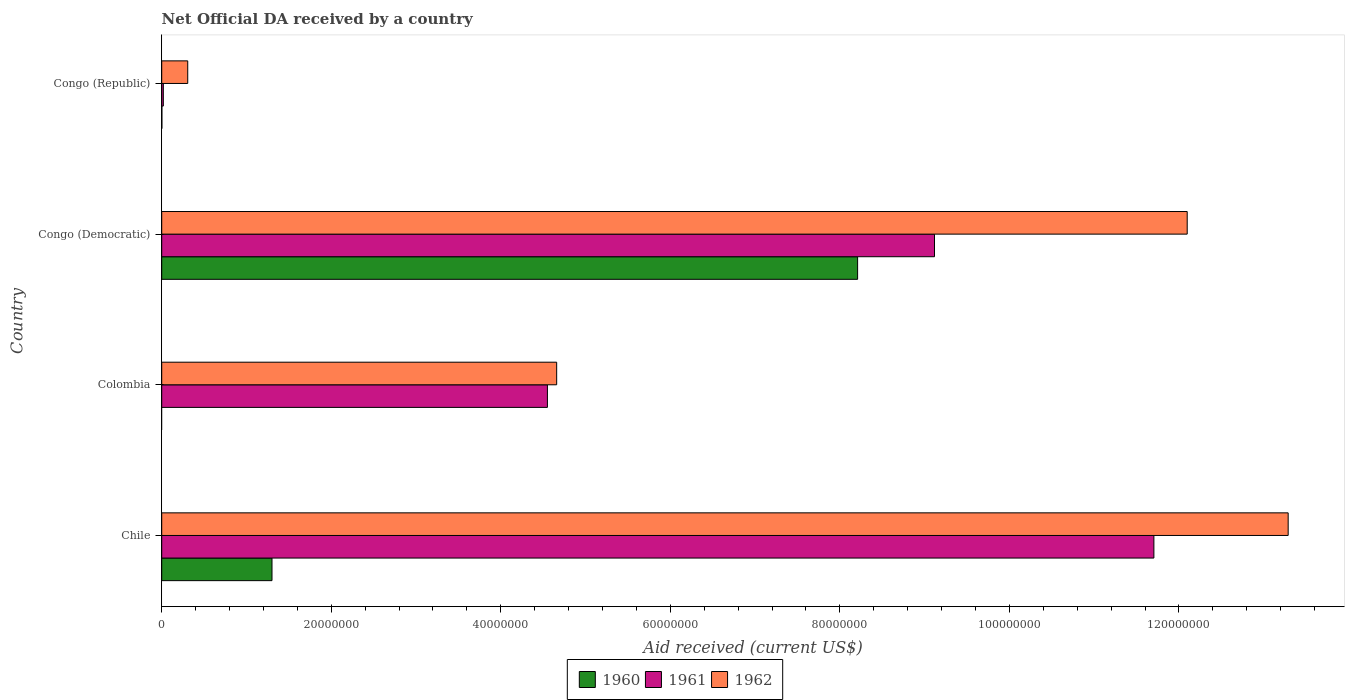How many different coloured bars are there?
Make the answer very short. 3. How many groups of bars are there?
Provide a short and direct response. 4. How many bars are there on the 1st tick from the top?
Offer a terse response. 3. What is the label of the 4th group of bars from the top?
Give a very brief answer. Chile. In how many cases, is the number of bars for a given country not equal to the number of legend labels?
Keep it short and to the point. 1. What is the net official development assistance aid received in 1962 in Chile?
Ensure brevity in your answer.  1.33e+08. Across all countries, what is the maximum net official development assistance aid received in 1962?
Make the answer very short. 1.33e+08. Across all countries, what is the minimum net official development assistance aid received in 1961?
Offer a terse response. 1.90e+05. In which country was the net official development assistance aid received in 1961 maximum?
Make the answer very short. Chile. What is the total net official development assistance aid received in 1961 in the graph?
Make the answer very short. 2.54e+08. What is the difference between the net official development assistance aid received in 1962 in Colombia and that in Congo (Democratic)?
Offer a terse response. -7.44e+07. What is the difference between the net official development assistance aid received in 1960 in Congo (Republic) and the net official development assistance aid received in 1961 in Colombia?
Your answer should be compact. -4.55e+07. What is the average net official development assistance aid received in 1960 per country?
Give a very brief answer. 2.38e+07. What is the difference between the net official development assistance aid received in 1962 and net official development assistance aid received in 1961 in Chile?
Ensure brevity in your answer.  1.58e+07. In how many countries, is the net official development assistance aid received in 1961 greater than 48000000 US$?
Give a very brief answer. 2. What is the ratio of the net official development assistance aid received in 1960 in Chile to that in Congo (Democratic)?
Your response must be concise. 0.16. What is the difference between the highest and the second highest net official development assistance aid received in 1962?
Provide a short and direct response. 1.19e+07. What is the difference between the highest and the lowest net official development assistance aid received in 1960?
Give a very brief answer. 8.21e+07. Is the sum of the net official development assistance aid received in 1960 in Chile and Congo (Democratic) greater than the maximum net official development assistance aid received in 1962 across all countries?
Provide a succinct answer. No. How many countries are there in the graph?
Your answer should be very brief. 4. What is the difference between two consecutive major ticks on the X-axis?
Provide a succinct answer. 2.00e+07. Are the values on the major ticks of X-axis written in scientific E-notation?
Your answer should be very brief. No. Does the graph contain any zero values?
Provide a succinct answer. Yes. Does the graph contain grids?
Offer a very short reply. No. Where does the legend appear in the graph?
Keep it short and to the point. Bottom center. How many legend labels are there?
Ensure brevity in your answer.  3. How are the legend labels stacked?
Make the answer very short. Horizontal. What is the title of the graph?
Provide a succinct answer. Net Official DA received by a country. What is the label or title of the X-axis?
Offer a very short reply. Aid received (current US$). What is the Aid received (current US$) of 1960 in Chile?
Offer a very short reply. 1.30e+07. What is the Aid received (current US$) of 1961 in Chile?
Keep it short and to the point. 1.17e+08. What is the Aid received (current US$) of 1962 in Chile?
Make the answer very short. 1.33e+08. What is the Aid received (current US$) of 1961 in Colombia?
Your response must be concise. 4.55e+07. What is the Aid received (current US$) of 1962 in Colombia?
Your response must be concise. 4.66e+07. What is the Aid received (current US$) in 1960 in Congo (Democratic)?
Keep it short and to the point. 8.21e+07. What is the Aid received (current US$) in 1961 in Congo (Democratic)?
Offer a terse response. 9.12e+07. What is the Aid received (current US$) of 1962 in Congo (Democratic)?
Ensure brevity in your answer.  1.21e+08. What is the Aid received (current US$) of 1960 in Congo (Republic)?
Provide a short and direct response. 2.00e+04. What is the Aid received (current US$) of 1962 in Congo (Republic)?
Make the answer very short. 3.07e+06. Across all countries, what is the maximum Aid received (current US$) of 1960?
Provide a succinct answer. 8.21e+07. Across all countries, what is the maximum Aid received (current US$) of 1961?
Offer a terse response. 1.17e+08. Across all countries, what is the maximum Aid received (current US$) in 1962?
Keep it short and to the point. 1.33e+08. Across all countries, what is the minimum Aid received (current US$) of 1961?
Keep it short and to the point. 1.90e+05. Across all countries, what is the minimum Aid received (current US$) in 1962?
Offer a terse response. 3.07e+06. What is the total Aid received (current US$) in 1960 in the graph?
Offer a terse response. 9.51e+07. What is the total Aid received (current US$) of 1961 in the graph?
Give a very brief answer. 2.54e+08. What is the total Aid received (current US$) in 1962 in the graph?
Offer a very short reply. 3.04e+08. What is the difference between the Aid received (current US$) of 1961 in Chile and that in Colombia?
Your response must be concise. 7.15e+07. What is the difference between the Aid received (current US$) of 1962 in Chile and that in Colombia?
Offer a terse response. 8.63e+07. What is the difference between the Aid received (current US$) of 1960 in Chile and that in Congo (Democratic)?
Make the answer very short. -6.91e+07. What is the difference between the Aid received (current US$) in 1961 in Chile and that in Congo (Democratic)?
Your response must be concise. 2.59e+07. What is the difference between the Aid received (current US$) of 1962 in Chile and that in Congo (Democratic)?
Your answer should be compact. 1.19e+07. What is the difference between the Aid received (current US$) in 1960 in Chile and that in Congo (Republic)?
Give a very brief answer. 1.30e+07. What is the difference between the Aid received (current US$) in 1961 in Chile and that in Congo (Republic)?
Provide a succinct answer. 1.17e+08. What is the difference between the Aid received (current US$) of 1962 in Chile and that in Congo (Republic)?
Your answer should be very brief. 1.30e+08. What is the difference between the Aid received (current US$) of 1961 in Colombia and that in Congo (Democratic)?
Offer a very short reply. -4.57e+07. What is the difference between the Aid received (current US$) in 1962 in Colombia and that in Congo (Democratic)?
Ensure brevity in your answer.  -7.44e+07. What is the difference between the Aid received (current US$) in 1961 in Colombia and that in Congo (Republic)?
Your answer should be very brief. 4.53e+07. What is the difference between the Aid received (current US$) in 1962 in Colombia and that in Congo (Republic)?
Offer a terse response. 4.35e+07. What is the difference between the Aid received (current US$) in 1960 in Congo (Democratic) and that in Congo (Republic)?
Give a very brief answer. 8.21e+07. What is the difference between the Aid received (current US$) of 1961 in Congo (Democratic) and that in Congo (Republic)?
Offer a terse response. 9.10e+07. What is the difference between the Aid received (current US$) in 1962 in Congo (Democratic) and that in Congo (Republic)?
Provide a succinct answer. 1.18e+08. What is the difference between the Aid received (current US$) of 1960 in Chile and the Aid received (current US$) of 1961 in Colombia?
Provide a succinct answer. -3.25e+07. What is the difference between the Aid received (current US$) in 1960 in Chile and the Aid received (current US$) in 1962 in Colombia?
Provide a succinct answer. -3.36e+07. What is the difference between the Aid received (current US$) of 1961 in Chile and the Aid received (current US$) of 1962 in Colombia?
Your response must be concise. 7.04e+07. What is the difference between the Aid received (current US$) of 1960 in Chile and the Aid received (current US$) of 1961 in Congo (Democratic)?
Your response must be concise. -7.82e+07. What is the difference between the Aid received (current US$) in 1960 in Chile and the Aid received (current US$) in 1962 in Congo (Democratic)?
Your answer should be compact. -1.08e+08. What is the difference between the Aid received (current US$) in 1961 in Chile and the Aid received (current US$) in 1962 in Congo (Democratic)?
Your response must be concise. -3.93e+06. What is the difference between the Aid received (current US$) of 1960 in Chile and the Aid received (current US$) of 1961 in Congo (Republic)?
Provide a succinct answer. 1.28e+07. What is the difference between the Aid received (current US$) in 1960 in Chile and the Aid received (current US$) in 1962 in Congo (Republic)?
Keep it short and to the point. 9.94e+06. What is the difference between the Aid received (current US$) in 1961 in Chile and the Aid received (current US$) in 1962 in Congo (Republic)?
Ensure brevity in your answer.  1.14e+08. What is the difference between the Aid received (current US$) in 1961 in Colombia and the Aid received (current US$) in 1962 in Congo (Democratic)?
Your response must be concise. -7.55e+07. What is the difference between the Aid received (current US$) in 1961 in Colombia and the Aid received (current US$) in 1962 in Congo (Republic)?
Keep it short and to the point. 4.24e+07. What is the difference between the Aid received (current US$) of 1960 in Congo (Democratic) and the Aid received (current US$) of 1961 in Congo (Republic)?
Offer a very short reply. 8.19e+07. What is the difference between the Aid received (current US$) in 1960 in Congo (Democratic) and the Aid received (current US$) in 1962 in Congo (Republic)?
Provide a succinct answer. 7.90e+07. What is the difference between the Aid received (current US$) of 1961 in Congo (Democratic) and the Aid received (current US$) of 1962 in Congo (Republic)?
Give a very brief answer. 8.81e+07. What is the average Aid received (current US$) in 1960 per country?
Provide a short and direct response. 2.38e+07. What is the average Aid received (current US$) in 1961 per country?
Offer a terse response. 6.35e+07. What is the average Aid received (current US$) of 1962 per country?
Your answer should be compact. 7.59e+07. What is the difference between the Aid received (current US$) of 1960 and Aid received (current US$) of 1961 in Chile?
Give a very brief answer. -1.04e+08. What is the difference between the Aid received (current US$) of 1960 and Aid received (current US$) of 1962 in Chile?
Your answer should be compact. -1.20e+08. What is the difference between the Aid received (current US$) in 1961 and Aid received (current US$) in 1962 in Chile?
Give a very brief answer. -1.58e+07. What is the difference between the Aid received (current US$) in 1961 and Aid received (current US$) in 1962 in Colombia?
Your answer should be compact. -1.09e+06. What is the difference between the Aid received (current US$) of 1960 and Aid received (current US$) of 1961 in Congo (Democratic)?
Make the answer very short. -9.07e+06. What is the difference between the Aid received (current US$) of 1960 and Aid received (current US$) of 1962 in Congo (Democratic)?
Provide a succinct answer. -3.89e+07. What is the difference between the Aid received (current US$) in 1961 and Aid received (current US$) in 1962 in Congo (Democratic)?
Provide a short and direct response. -2.98e+07. What is the difference between the Aid received (current US$) of 1960 and Aid received (current US$) of 1961 in Congo (Republic)?
Your answer should be compact. -1.70e+05. What is the difference between the Aid received (current US$) of 1960 and Aid received (current US$) of 1962 in Congo (Republic)?
Keep it short and to the point. -3.05e+06. What is the difference between the Aid received (current US$) in 1961 and Aid received (current US$) in 1962 in Congo (Republic)?
Your answer should be very brief. -2.88e+06. What is the ratio of the Aid received (current US$) in 1961 in Chile to that in Colombia?
Your response must be concise. 2.57. What is the ratio of the Aid received (current US$) in 1962 in Chile to that in Colombia?
Your answer should be very brief. 2.85. What is the ratio of the Aid received (current US$) of 1960 in Chile to that in Congo (Democratic)?
Give a very brief answer. 0.16. What is the ratio of the Aid received (current US$) in 1961 in Chile to that in Congo (Democratic)?
Your answer should be very brief. 1.28. What is the ratio of the Aid received (current US$) of 1962 in Chile to that in Congo (Democratic)?
Offer a terse response. 1.1. What is the ratio of the Aid received (current US$) of 1960 in Chile to that in Congo (Republic)?
Your answer should be compact. 650.5. What is the ratio of the Aid received (current US$) in 1961 in Chile to that in Congo (Republic)?
Your answer should be compact. 616. What is the ratio of the Aid received (current US$) in 1962 in Chile to that in Congo (Republic)?
Ensure brevity in your answer.  43.28. What is the ratio of the Aid received (current US$) of 1961 in Colombia to that in Congo (Democratic)?
Keep it short and to the point. 0.5. What is the ratio of the Aid received (current US$) in 1962 in Colombia to that in Congo (Democratic)?
Keep it short and to the point. 0.39. What is the ratio of the Aid received (current US$) of 1961 in Colombia to that in Congo (Republic)?
Your answer should be very brief. 239.47. What is the ratio of the Aid received (current US$) in 1962 in Colombia to that in Congo (Republic)?
Offer a terse response. 15.18. What is the ratio of the Aid received (current US$) in 1960 in Congo (Democratic) to that in Congo (Republic)?
Keep it short and to the point. 4104.5. What is the ratio of the Aid received (current US$) in 1961 in Congo (Democratic) to that in Congo (Republic)?
Your answer should be compact. 479.79. What is the ratio of the Aid received (current US$) in 1962 in Congo (Democratic) to that in Congo (Republic)?
Provide a short and direct response. 39.4. What is the difference between the highest and the second highest Aid received (current US$) of 1960?
Your response must be concise. 6.91e+07. What is the difference between the highest and the second highest Aid received (current US$) of 1961?
Ensure brevity in your answer.  2.59e+07. What is the difference between the highest and the second highest Aid received (current US$) in 1962?
Provide a short and direct response. 1.19e+07. What is the difference between the highest and the lowest Aid received (current US$) in 1960?
Provide a succinct answer. 8.21e+07. What is the difference between the highest and the lowest Aid received (current US$) in 1961?
Provide a succinct answer. 1.17e+08. What is the difference between the highest and the lowest Aid received (current US$) of 1962?
Provide a succinct answer. 1.30e+08. 